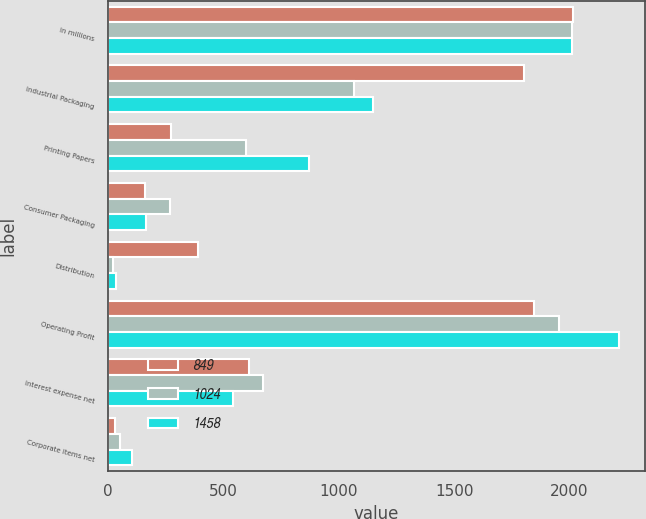Convert chart. <chart><loc_0><loc_0><loc_500><loc_500><stacked_bar_chart><ecel><fcel>In millions<fcel>Industrial Packaging<fcel>Printing Papers<fcel>Consumer Packaging<fcel>Distribution<fcel>Operating Profit<fcel>Interest expense net<fcel>Corporate items net<nl><fcel>849<fcel>2013<fcel>1801<fcel>271<fcel>161<fcel>389<fcel>1844<fcel>612<fcel>29<nl><fcel>1024<fcel>2012<fcel>1066<fcel>599<fcel>268<fcel>22<fcel>1955<fcel>672<fcel>51<nl><fcel>1458<fcel>2011<fcel>1147<fcel>872<fcel>163<fcel>34<fcel>2216<fcel>541<fcel>102<nl></chart> 